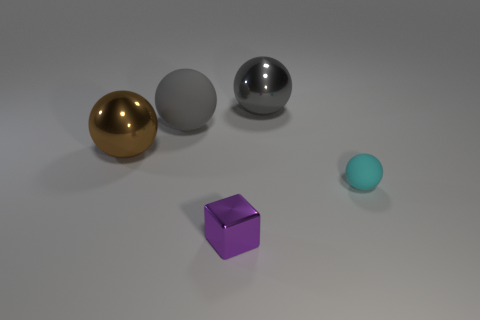How many balls are to the right of the block and behind the cyan thing?
Make the answer very short. 1. Does the rubber object right of the large gray shiny thing have the same shape as the large brown shiny object?
Offer a terse response. Yes. There is a gray object that is the same size as the gray shiny sphere; what material is it?
Provide a succinct answer. Rubber. Are there an equal number of tiny cyan objects that are left of the large brown thing and brown balls that are in front of the tiny purple shiny block?
Offer a very short reply. Yes. What number of gray shiny spheres are behind the rubber object that is to the left of the shiny object that is in front of the tiny cyan object?
Your answer should be very brief. 1. There is a small metal block; is its color the same as the large shiny ball on the left side of the tiny metallic block?
Make the answer very short. No. There is a purple block that is the same material as the big brown object; what size is it?
Your answer should be compact. Small. Is the number of small blocks behind the big rubber sphere greater than the number of big gray matte things?
Your answer should be very brief. No. There is a cube that is right of the rubber object that is to the left of the matte object that is in front of the brown shiny ball; what is it made of?
Ensure brevity in your answer.  Metal. Does the small sphere have the same material as the big ball on the right side of the purple object?
Provide a succinct answer. No. 